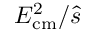Convert formula to latex. <formula><loc_0><loc_0><loc_500><loc_500>E _ { c m } ^ { 2 } / { \hat { s } }</formula> 